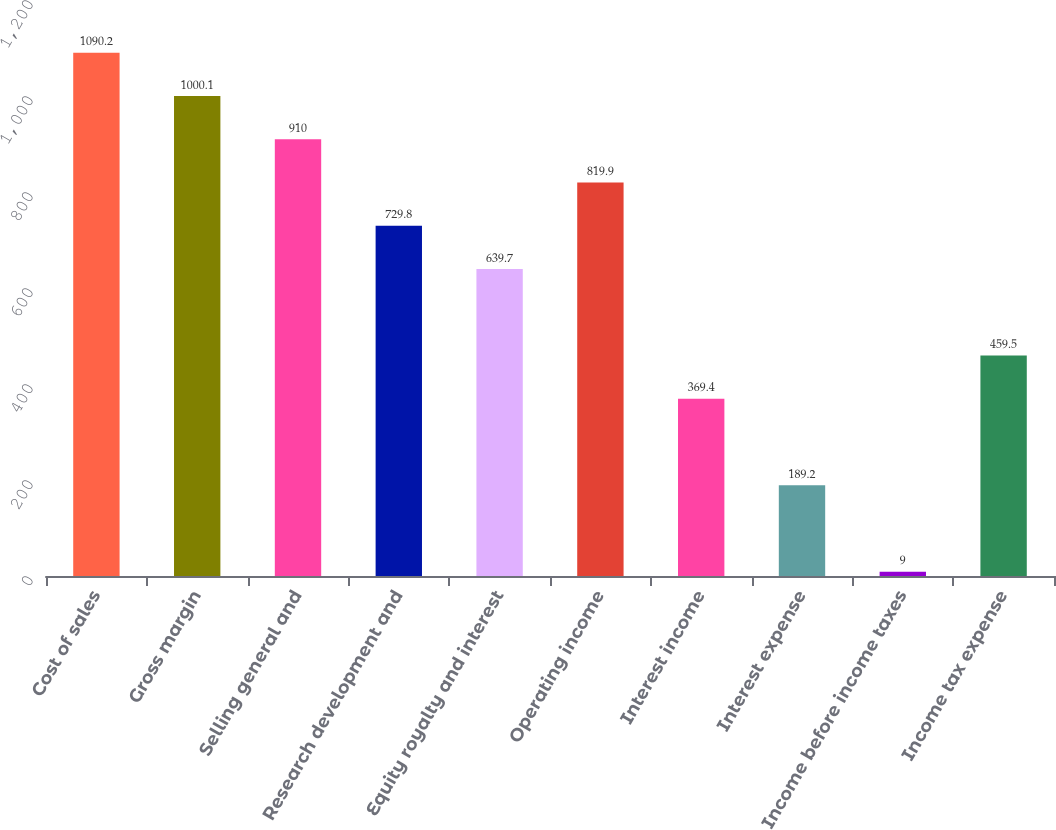Convert chart to OTSL. <chart><loc_0><loc_0><loc_500><loc_500><bar_chart><fcel>Cost of sales<fcel>Gross margin<fcel>Selling general and<fcel>Research development and<fcel>Equity royalty and interest<fcel>Operating income<fcel>Interest income<fcel>Interest expense<fcel>Income before income taxes<fcel>Income tax expense<nl><fcel>1090.2<fcel>1000.1<fcel>910<fcel>729.8<fcel>639.7<fcel>819.9<fcel>369.4<fcel>189.2<fcel>9<fcel>459.5<nl></chart> 